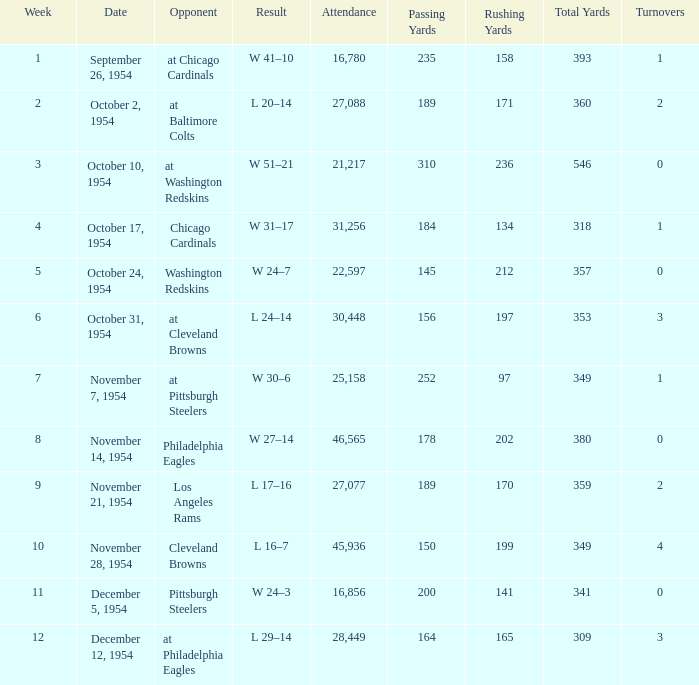How many weeks have october 31, 1954 as the date? 1.0. 